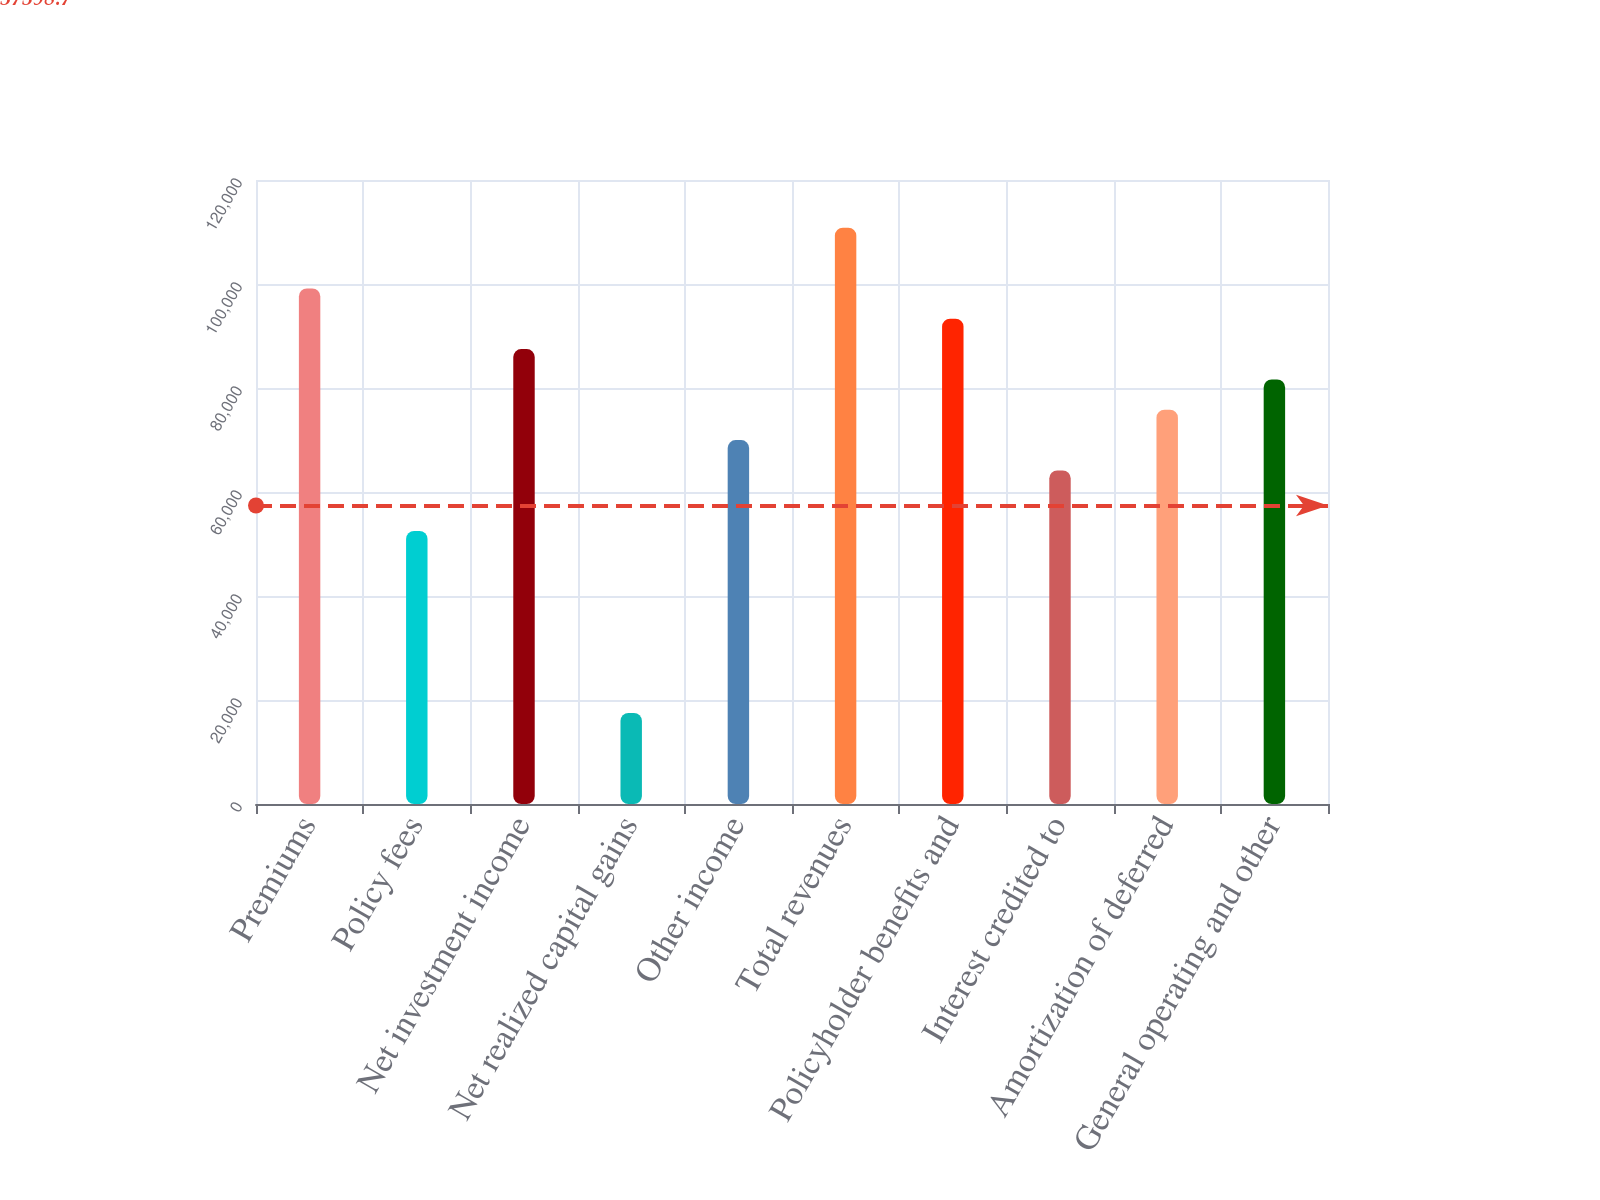Convert chart to OTSL. <chart><loc_0><loc_0><loc_500><loc_500><bar_chart><fcel>Premiums<fcel>Policy fees<fcel>Net investment income<fcel>Net realized capital gains<fcel>Other income<fcel>Total revenues<fcel>Policyholder benefits and<fcel>Interest credited to<fcel>Amortization of deferred<fcel>General operating and other<nl><fcel>99148.2<fcel>52495.4<fcel>87485<fcel>17505.8<fcel>69990.2<fcel>110811<fcel>93316.6<fcel>64158.6<fcel>75821.8<fcel>81653.4<nl></chart> 